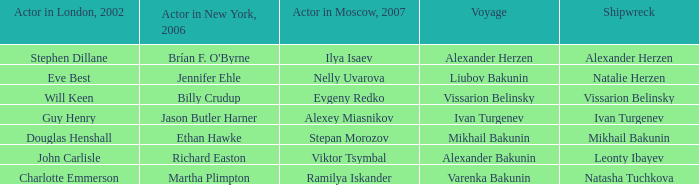Who was the 2007 actor from Moscow for the voyage of Varenka Bakunin? Ramilya Iskander. 